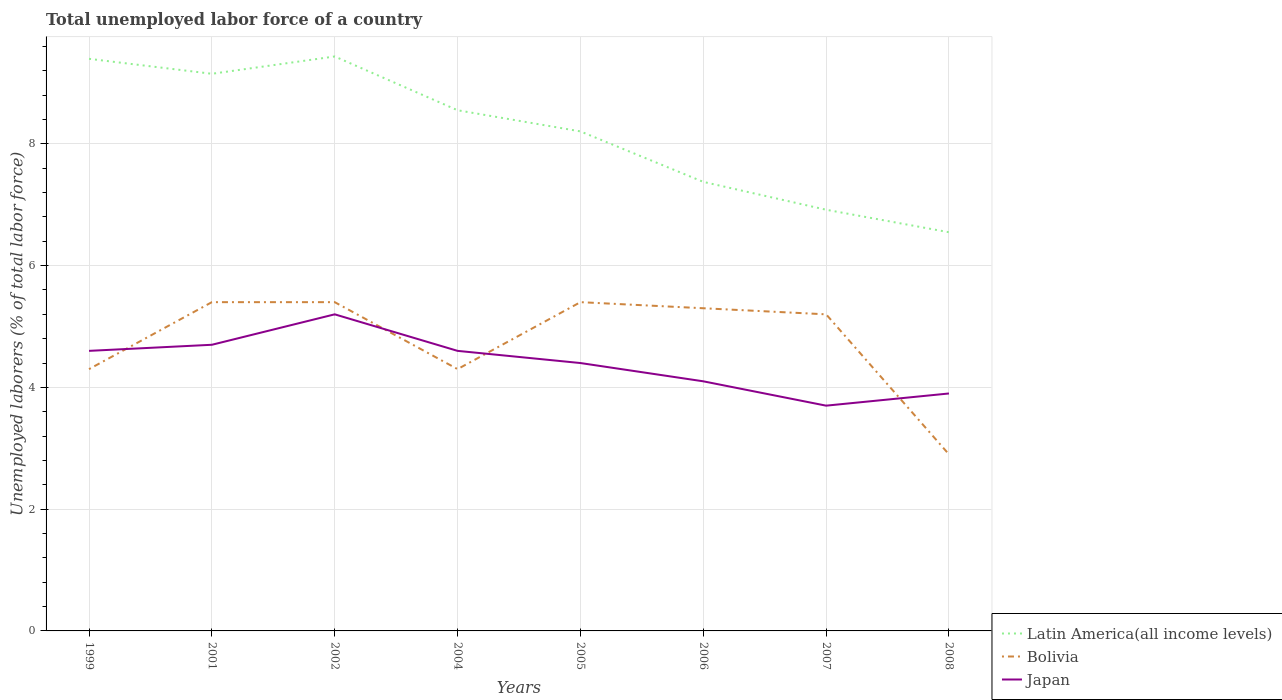Does the line corresponding to Bolivia intersect with the line corresponding to Latin America(all income levels)?
Offer a terse response. No. Is the number of lines equal to the number of legend labels?
Give a very brief answer. Yes. Across all years, what is the maximum total unemployed labor force in Latin America(all income levels)?
Your response must be concise. 6.55. In which year was the total unemployed labor force in Japan maximum?
Your response must be concise. 2007. What is the total total unemployed labor force in Japan in the graph?
Your answer should be compact. 0.9. What is the difference between the highest and the second highest total unemployed labor force in Bolivia?
Offer a terse response. 2.5. Is the total unemployed labor force in Bolivia strictly greater than the total unemployed labor force in Japan over the years?
Keep it short and to the point. No. How many years are there in the graph?
Give a very brief answer. 8. What is the difference between two consecutive major ticks on the Y-axis?
Your answer should be compact. 2. Are the values on the major ticks of Y-axis written in scientific E-notation?
Your answer should be compact. No. Does the graph contain grids?
Provide a succinct answer. Yes. How are the legend labels stacked?
Make the answer very short. Vertical. What is the title of the graph?
Your answer should be compact. Total unemployed labor force of a country. Does "Azerbaijan" appear as one of the legend labels in the graph?
Ensure brevity in your answer.  No. What is the label or title of the X-axis?
Offer a terse response. Years. What is the label or title of the Y-axis?
Your response must be concise. Unemployed laborers (% of total labor force). What is the Unemployed laborers (% of total labor force) of Latin America(all income levels) in 1999?
Your answer should be compact. 9.4. What is the Unemployed laborers (% of total labor force) of Bolivia in 1999?
Provide a short and direct response. 4.3. What is the Unemployed laborers (% of total labor force) of Japan in 1999?
Your answer should be very brief. 4.6. What is the Unemployed laborers (% of total labor force) of Latin America(all income levels) in 2001?
Your answer should be very brief. 9.15. What is the Unemployed laborers (% of total labor force) in Bolivia in 2001?
Your answer should be very brief. 5.4. What is the Unemployed laborers (% of total labor force) of Japan in 2001?
Your answer should be very brief. 4.7. What is the Unemployed laborers (% of total labor force) of Latin America(all income levels) in 2002?
Give a very brief answer. 9.44. What is the Unemployed laborers (% of total labor force) of Bolivia in 2002?
Your answer should be compact. 5.4. What is the Unemployed laborers (% of total labor force) in Japan in 2002?
Ensure brevity in your answer.  5.2. What is the Unemployed laborers (% of total labor force) of Latin America(all income levels) in 2004?
Offer a terse response. 8.55. What is the Unemployed laborers (% of total labor force) of Bolivia in 2004?
Provide a short and direct response. 4.3. What is the Unemployed laborers (% of total labor force) in Japan in 2004?
Offer a very short reply. 4.6. What is the Unemployed laborers (% of total labor force) in Latin America(all income levels) in 2005?
Give a very brief answer. 8.2. What is the Unemployed laborers (% of total labor force) of Bolivia in 2005?
Your answer should be compact. 5.4. What is the Unemployed laborers (% of total labor force) in Japan in 2005?
Offer a very short reply. 4.4. What is the Unemployed laborers (% of total labor force) of Latin America(all income levels) in 2006?
Your answer should be compact. 7.38. What is the Unemployed laborers (% of total labor force) of Bolivia in 2006?
Offer a very short reply. 5.3. What is the Unemployed laborers (% of total labor force) of Japan in 2006?
Make the answer very short. 4.1. What is the Unemployed laborers (% of total labor force) in Latin America(all income levels) in 2007?
Offer a terse response. 6.92. What is the Unemployed laborers (% of total labor force) in Bolivia in 2007?
Your answer should be very brief. 5.2. What is the Unemployed laborers (% of total labor force) of Japan in 2007?
Provide a short and direct response. 3.7. What is the Unemployed laborers (% of total labor force) in Latin America(all income levels) in 2008?
Give a very brief answer. 6.55. What is the Unemployed laborers (% of total labor force) of Bolivia in 2008?
Provide a succinct answer. 2.9. What is the Unemployed laborers (% of total labor force) of Japan in 2008?
Give a very brief answer. 3.9. Across all years, what is the maximum Unemployed laborers (% of total labor force) of Latin America(all income levels)?
Offer a very short reply. 9.44. Across all years, what is the maximum Unemployed laborers (% of total labor force) of Bolivia?
Ensure brevity in your answer.  5.4. Across all years, what is the maximum Unemployed laborers (% of total labor force) of Japan?
Provide a succinct answer. 5.2. Across all years, what is the minimum Unemployed laborers (% of total labor force) in Latin America(all income levels)?
Your response must be concise. 6.55. Across all years, what is the minimum Unemployed laborers (% of total labor force) in Bolivia?
Your answer should be very brief. 2.9. Across all years, what is the minimum Unemployed laborers (% of total labor force) of Japan?
Ensure brevity in your answer.  3.7. What is the total Unemployed laborers (% of total labor force) in Latin America(all income levels) in the graph?
Your answer should be very brief. 65.58. What is the total Unemployed laborers (% of total labor force) in Bolivia in the graph?
Give a very brief answer. 38.2. What is the total Unemployed laborers (% of total labor force) of Japan in the graph?
Make the answer very short. 35.2. What is the difference between the Unemployed laborers (% of total labor force) in Latin America(all income levels) in 1999 and that in 2001?
Provide a succinct answer. 0.25. What is the difference between the Unemployed laborers (% of total labor force) in Latin America(all income levels) in 1999 and that in 2002?
Offer a terse response. -0.04. What is the difference between the Unemployed laborers (% of total labor force) of Japan in 1999 and that in 2002?
Make the answer very short. -0.6. What is the difference between the Unemployed laborers (% of total labor force) in Latin America(all income levels) in 1999 and that in 2004?
Offer a very short reply. 0.84. What is the difference between the Unemployed laborers (% of total labor force) of Bolivia in 1999 and that in 2004?
Your response must be concise. 0. What is the difference between the Unemployed laborers (% of total labor force) of Japan in 1999 and that in 2004?
Offer a very short reply. 0. What is the difference between the Unemployed laborers (% of total labor force) of Latin America(all income levels) in 1999 and that in 2005?
Provide a succinct answer. 1.19. What is the difference between the Unemployed laborers (% of total labor force) of Latin America(all income levels) in 1999 and that in 2006?
Provide a succinct answer. 2.02. What is the difference between the Unemployed laborers (% of total labor force) of Bolivia in 1999 and that in 2006?
Keep it short and to the point. -1. What is the difference between the Unemployed laborers (% of total labor force) of Japan in 1999 and that in 2006?
Make the answer very short. 0.5. What is the difference between the Unemployed laborers (% of total labor force) of Latin America(all income levels) in 1999 and that in 2007?
Offer a terse response. 2.48. What is the difference between the Unemployed laborers (% of total labor force) of Bolivia in 1999 and that in 2007?
Provide a succinct answer. -0.9. What is the difference between the Unemployed laborers (% of total labor force) in Latin America(all income levels) in 1999 and that in 2008?
Your answer should be compact. 2.85. What is the difference between the Unemployed laborers (% of total labor force) of Latin America(all income levels) in 2001 and that in 2002?
Your answer should be compact. -0.28. What is the difference between the Unemployed laborers (% of total labor force) in Japan in 2001 and that in 2002?
Make the answer very short. -0.5. What is the difference between the Unemployed laborers (% of total labor force) of Latin America(all income levels) in 2001 and that in 2004?
Your answer should be compact. 0.6. What is the difference between the Unemployed laborers (% of total labor force) in Latin America(all income levels) in 2001 and that in 2005?
Give a very brief answer. 0.95. What is the difference between the Unemployed laborers (% of total labor force) in Bolivia in 2001 and that in 2005?
Ensure brevity in your answer.  0. What is the difference between the Unemployed laborers (% of total labor force) in Japan in 2001 and that in 2005?
Give a very brief answer. 0.3. What is the difference between the Unemployed laborers (% of total labor force) of Latin America(all income levels) in 2001 and that in 2006?
Provide a short and direct response. 1.78. What is the difference between the Unemployed laborers (% of total labor force) in Japan in 2001 and that in 2006?
Make the answer very short. 0.6. What is the difference between the Unemployed laborers (% of total labor force) of Latin America(all income levels) in 2001 and that in 2007?
Your answer should be compact. 2.23. What is the difference between the Unemployed laborers (% of total labor force) in Latin America(all income levels) in 2001 and that in 2008?
Give a very brief answer. 2.6. What is the difference between the Unemployed laborers (% of total labor force) in Bolivia in 2001 and that in 2008?
Make the answer very short. 2.5. What is the difference between the Unemployed laborers (% of total labor force) of Latin America(all income levels) in 2002 and that in 2004?
Your answer should be very brief. 0.88. What is the difference between the Unemployed laborers (% of total labor force) of Japan in 2002 and that in 2004?
Offer a terse response. 0.6. What is the difference between the Unemployed laborers (% of total labor force) of Latin America(all income levels) in 2002 and that in 2005?
Provide a succinct answer. 1.23. What is the difference between the Unemployed laborers (% of total labor force) in Bolivia in 2002 and that in 2005?
Provide a short and direct response. 0. What is the difference between the Unemployed laborers (% of total labor force) in Latin America(all income levels) in 2002 and that in 2006?
Your answer should be very brief. 2.06. What is the difference between the Unemployed laborers (% of total labor force) in Latin America(all income levels) in 2002 and that in 2007?
Offer a terse response. 2.52. What is the difference between the Unemployed laborers (% of total labor force) in Latin America(all income levels) in 2002 and that in 2008?
Your response must be concise. 2.89. What is the difference between the Unemployed laborers (% of total labor force) in Japan in 2002 and that in 2008?
Give a very brief answer. 1.3. What is the difference between the Unemployed laborers (% of total labor force) of Latin America(all income levels) in 2004 and that in 2005?
Make the answer very short. 0.35. What is the difference between the Unemployed laborers (% of total labor force) in Bolivia in 2004 and that in 2005?
Make the answer very short. -1.1. What is the difference between the Unemployed laborers (% of total labor force) of Latin America(all income levels) in 2004 and that in 2006?
Your answer should be compact. 1.18. What is the difference between the Unemployed laborers (% of total labor force) in Japan in 2004 and that in 2006?
Make the answer very short. 0.5. What is the difference between the Unemployed laborers (% of total labor force) in Latin America(all income levels) in 2004 and that in 2007?
Your response must be concise. 1.63. What is the difference between the Unemployed laborers (% of total labor force) of Japan in 2004 and that in 2007?
Keep it short and to the point. 0.9. What is the difference between the Unemployed laborers (% of total labor force) in Latin America(all income levels) in 2004 and that in 2008?
Your answer should be compact. 2. What is the difference between the Unemployed laborers (% of total labor force) of Latin America(all income levels) in 2005 and that in 2006?
Your answer should be compact. 0.83. What is the difference between the Unemployed laborers (% of total labor force) of Latin America(all income levels) in 2005 and that in 2007?
Your answer should be very brief. 1.29. What is the difference between the Unemployed laborers (% of total labor force) of Latin America(all income levels) in 2005 and that in 2008?
Offer a terse response. 1.66. What is the difference between the Unemployed laborers (% of total labor force) in Bolivia in 2005 and that in 2008?
Provide a succinct answer. 2.5. What is the difference between the Unemployed laborers (% of total labor force) of Japan in 2005 and that in 2008?
Your answer should be compact. 0.5. What is the difference between the Unemployed laborers (% of total labor force) in Latin America(all income levels) in 2006 and that in 2007?
Your response must be concise. 0.46. What is the difference between the Unemployed laborers (% of total labor force) in Latin America(all income levels) in 2006 and that in 2008?
Provide a succinct answer. 0.83. What is the difference between the Unemployed laborers (% of total labor force) of Japan in 2006 and that in 2008?
Keep it short and to the point. 0.2. What is the difference between the Unemployed laborers (% of total labor force) in Latin America(all income levels) in 2007 and that in 2008?
Offer a terse response. 0.37. What is the difference between the Unemployed laborers (% of total labor force) in Bolivia in 2007 and that in 2008?
Provide a succinct answer. 2.3. What is the difference between the Unemployed laborers (% of total labor force) of Japan in 2007 and that in 2008?
Give a very brief answer. -0.2. What is the difference between the Unemployed laborers (% of total labor force) in Latin America(all income levels) in 1999 and the Unemployed laborers (% of total labor force) in Bolivia in 2001?
Keep it short and to the point. 4. What is the difference between the Unemployed laborers (% of total labor force) of Latin America(all income levels) in 1999 and the Unemployed laborers (% of total labor force) of Japan in 2001?
Your response must be concise. 4.7. What is the difference between the Unemployed laborers (% of total labor force) in Bolivia in 1999 and the Unemployed laborers (% of total labor force) in Japan in 2001?
Give a very brief answer. -0.4. What is the difference between the Unemployed laborers (% of total labor force) of Latin America(all income levels) in 1999 and the Unemployed laborers (% of total labor force) of Bolivia in 2002?
Provide a short and direct response. 4. What is the difference between the Unemployed laborers (% of total labor force) in Latin America(all income levels) in 1999 and the Unemployed laborers (% of total labor force) in Japan in 2002?
Offer a very short reply. 4.2. What is the difference between the Unemployed laborers (% of total labor force) in Latin America(all income levels) in 1999 and the Unemployed laborers (% of total labor force) in Bolivia in 2004?
Your answer should be very brief. 5.1. What is the difference between the Unemployed laborers (% of total labor force) of Latin America(all income levels) in 1999 and the Unemployed laborers (% of total labor force) of Japan in 2004?
Provide a succinct answer. 4.8. What is the difference between the Unemployed laborers (% of total labor force) of Bolivia in 1999 and the Unemployed laborers (% of total labor force) of Japan in 2004?
Keep it short and to the point. -0.3. What is the difference between the Unemployed laborers (% of total labor force) in Latin America(all income levels) in 1999 and the Unemployed laborers (% of total labor force) in Bolivia in 2005?
Offer a terse response. 4. What is the difference between the Unemployed laborers (% of total labor force) of Latin America(all income levels) in 1999 and the Unemployed laborers (% of total labor force) of Japan in 2005?
Ensure brevity in your answer.  5. What is the difference between the Unemployed laborers (% of total labor force) in Latin America(all income levels) in 1999 and the Unemployed laborers (% of total labor force) in Bolivia in 2006?
Give a very brief answer. 4.1. What is the difference between the Unemployed laborers (% of total labor force) of Latin America(all income levels) in 1999 and the Unemployed laborers (% of total labor force) of Japan in 2006?
Provide a short and direct response. 5.3. What is the difference between the Unemployed laborers (% of total labor force) in Latin America(all income levels) in 1999 and the Unemployed laborers (% of total labor force) in Bolivia in 2007?
Your response must be concise. 4.2. What is the difference between the Unemployed laborers (% of total labor force) in Latin America(all income levels) in 1999 and the Unemployed laborers (% of total labor force) in Japan in 2007?
Provide a short and direct response. 5.7. What is the difference between the Unemployed laborers (% of total labor force) in Bolivia in 1999 and the Unemployed laborers (% of total labor force) in Japan in 2007?
Offer a very short reply. 0.6. What is the difference between the Unemployed laborers (% of total labor force) of Latin America(all income levels) in 1999 and the Unemployed laborers (% of total labor force) of Bolivia in 2008?
Your answer should be very brief. 6.5. What is the difference between the Unemployed laborers (% of total labor force) of Latin America(all income levels) in 1999 and the Unemployed laborers (% of total labor force) of Japan in 2008?
Your answer should be very brief. 5.5. What is the difference between the Unemployed laborers (% of total labor force) of Bolivia in 1999 and the Unemployed laborers (% of total labor force) of Japan in 2008?
Offer a terse response. 0.4. What is the difference between the Unemployed laborers (% of total labor force) of Latin America(all income levels) in 2001 and the Unemployed laborers (% of total labor force) of Bolivia in 2002?
Your answer should be compact. 3.75. What is the difference between the Unemployed laborers (% of total labor force) of Latin America(all income levels) in 2001 and the Unemployed laborers (% of total labor force) of Japan in 2002?
Your response must be concise. 3.95. What is the difference between the Unemployed laborers (% of total labor force) in Latin America(all income levels) in 2001 and the Unemployed laborers (% of total labor force) in Bolivia in 2004?
Keep it short and to the point. 4.85. What is the difference between the Unemployed laborers (% of total labor force) in Latin America(all income levels) in 2001 and the Unemployed laborers (% of total labor force) in Japan in 2004?
Ensure brevity in your answer.  4.55. What is the difference between the Unemployed laborers (% of total labor force) in Latin America(all income levels) in 2001 and the Unemployed laborers (% of total labor force) in Bolivia in 2005?
Ensure brevity in your answer.  3.75. What is the difference between the Unemployed laborers (% of total labor force) in Latin America(all income levels) in 2001 and the Unemployed laborers (% of total labor force) in Japan in 2005?
Provide a succinct answer. 4.75. What is the difference between the Unemployed laborers (% of total labor force) in Bolivia in 2001 and the Unemployed laborers (% of total labor force) in Japan in 2005?
Make the answer very short. 1. What is the difference between the Unemployed laborers (% of total labor force) in Latin America(all income levels) in 2001 and the Unemployed laborers (% of total labor force) in Bolivia in 2006?
Your answer should be very brief. 3.85. What is the difference between the Unemployed laborers (% of total labor force) of Latin America(all income levels) in 2001 and the Unemployed laborers (% of total labor force) of Japan in 2006?
Provide a short and direct response. 5.05. What is the difference between the Unemployed laborers (% of total labor force) of Bolivia in 2001 and the Unemployed laborers (% of total labor force) of Japan in 2006?
Your response must be concise. 1.3. What is the difference between the Unemployed laborers (% of total labor force) in Latin America(all income levels) in 2001 and the Unemployed laborers (% of total labor force) in Bolivia in 2007?
Offer a terse response. 3.95. What is the difference between the Unemployed laborers (% of total labor force) of Latin America(all income levels) in 2001 and the Unemployed laborers (% of total labor force) of Japan in 2007?
Your answer should be compact. 5.45. What is the difference between the Unemployed laborers (% of total labor force) in Bolivia in 2001 and the Unemployed laborers (% of total labor force) in Japan in 2007?
Make the answer very short. 1.7. What is the difference between the Unemployed laborers (% of total labor force) in Latin America(all income levels) in 2001 and the Unemployed laborers (% of total labor force) in Bolivia in 2008?
Offer a terse response. 6.25. What is the difference between the Unemployed laborers (% of total labor force) in Latin America(all income levels) in 2001 and the Unemployed laborers (% of total labor force) in Japan in 2008?
Give a very brief answer. 5.25. What is the difference between the Unemployed laborers (% of total labor force) in Latin America(all income levels) in 2002 and the Unemployed laborers (% of total labor force) in Bolivia in 2004?
Provide a succinct answer. 5.14. What is the difference between the Unemployed laborers (% of total labor force) of Latin America(all income levels) in 2002 and the Unemployed laborers (% of total labor force) of Japan in 2004?
Your response must be concise. 4.84. What is the difference between the Unemployed laborers (% of total labor force) of Bolivia in 2002 and the Unemployed laborers (% of total labor force) of Japan in 2004?
Ensure brevity in your answer.  0.8. What is the difference between the Unemployed laborers (% of total labor force) in Latin America(all income levels) in 2002 and the Unemployed laborers (% of total labor force) in Bolivia in 2005?
Provide a short and direct response. 4.04. What is the difference between the Unemployed laborers (% of total labor force) of Latin America(all income levels) in 2002 and the Unemployed laborers (% of total labor force) of Japan in 2005?
Your response must be concise. 5.04. What is the difference between the Unemployed laborers (% of total labor force) in Bolivia in 2002 and the Unemployed laborers (% of total labor force) in Japan in 2005?
Make the answer very short. 1. What is the difference between the Unemployed laborers (% of total labor force) of Latin America(all income levels) in 2002 and the Unemployed laborers (% of total labor force) of Bolivia in 2006?
Offer a very short reply. 4.14. What is the difference between the Unemployed laborers (% of total labor force) in Latin America(all income levels) in 2002 and the Unemployed laborers (% of total labor force) in Japan in 2006?
Ensure brevity in your answer.  5.34. What is the difference between the Unemployed laborers (% of total labor force) of Bolivia in 2002 and the Unemployed laborers (% of total labor force) of Japan in 2006?
Provide a succinct answer. 1.3. What is the difference between the Unemployed laborers (% of total labor force) in Latin America(all income levels) in 2002 and the Unemployed laborers (% of total labor force) in Bolivia in 2007?
Provide a short and direct response. 4.24. What is the difference between the Unemployed laborers (% of total labor force) of Latin America(all income levels) in 2002 and the Unemployed laborers (% of total labor force) of Japan in 2007?
Make the answer very short. 5.74. What is the difference between the Unemployed laborers (% of total labor force) in Bolivia in 2002 and the Unemployed laborers (% of total labor force) in Japan in 2007?
Your response must be concise. 1.7. What is the difference between the Unemployed laborers (% of total labor force) in Latin America(all income levels) in 2002 and the Unemployed laborers (% of total labor force) in Bolivia in 2008?
Offer a very short reply. 6.54. What is the difference between the Unemployed laborers (% of total labor force) in Latin America(all income levels) in 2002 and the Unemployed laborers (% of total labor force) in Japan in 2008?
Provide a succinct answer. 5.54. What is the difference between the Unemployed laborers (% of total labor force) of Bolivia in 2002 and the Unemployed laborers (% of total labor force) of Japan in 2008?
Provide a short and direct response. 1.5. What is the difference between the Unemployed laborers (% of total labor force) in Latin America(all income levels) in 2004 and the Unemployed laborers (% of total labor force) in Bolivia in 2005?
Your answer should be compact. 3.15. What is the difference between the Unemployed laborers (% of total labor force) in Latin America(all income levels) in 2004 and the Unemployed laborers (% of total labor force) in Japan in 2005?
Offer a terse response. 4.15. What is the difference between the Unemployed laborers (% of total labor force) of Latin America(all income levels) in 2004 and the Unemployed laborers (% of total labor force) of Bolivia in 2006?
Give a very brief answer. 3.25. What is the difference between the Unemployed laborers (% of total labor force) in Latin America(all income levels) in 2004 and the Unemployed laborers (% of total labor force) in Japan in 2006?
Offer a very short reply. 4.45. What is the difference between the Unemployed laborers (% of total labor force) of Latin America(all income levels) in 2004 and the Unemployed laborers (% of total labor force) of Bolivia in 2007?
Offer a very short reply. 3.35. What is the difference between the Unemployed laborers (% of total labor force) in Latin America(all income levels) in 2004 and the Unemployed laborers (% of total labor force) in Japan in 2007?
Your answer should be very brief. 4.85. What is the difference between the Unemployed laborers (% of total labor force) of Latin America(all income levels) in 2004 and the Unemployed laborers (% of total labor force) of Bolivia in 2008?
Provide a short and direct response. 5.65. What is the difference between the Unemployed laborers (% of total labor force) of Latin America(all income levels) in 2004 and the Unemployed laborers (% of total labor force) of Japan in 2008?
Your response must be concise. 4.65. What is the difference between the Unemployed laborers (% of total labor force) in Bolivia in 2004 and the Unemployed laborers (% of total labor force) in Japan in 2008?
Provide a succinct answer. 0.4. What is the difference between the Unemployed laborers (% of total labor force) of Latin America(all income levels) in 2005 and the Unemployed laborers (% of total labor force) of Bolivia in 2006?
Offer a very short reply. 2.9. What is the difference between the Unemployed laborers (% of total labor force) of Latin America(all income levels) in 2005 and the Unemployed laborers (% of total labor force) of Japan in 2006?
Make the answer very short. 4.1. What is the difference between the Unemployed laborers (% of total labor force) in Latin America(all income levels) in 2005 and the Unemployed laborers (% of total labor force) in Bolivia in 2007?
Your response must be concise. 3. What is the difference between the Unemployed laborers (% of total labor force) in Latin America(all income levels) in 2005 and the Unemployed laborers (% of total labor force) in Japan in 2007?
Provide a succinct answer. 4.5. What is the difference between the Unemployed laborers (% of total labor force) in Bolivia in 2005 and the Unemployed laborers (% of total labor force) in Japan in 2007?
Ensure brevity in your answer.  1.7. What is the difference between the Unemployed laborers (% of total labor force) in Latin America(all income levels) in 2005 and the Unemployed laborers (% of total labor force) in Bolivia in 2008?
Your answer should be very brief. 5.3. What is the difference between the Unemployed laborers (% of total labor force) in Latin America(all income levels) in 2005 and the Unemployed laborers (% of total labor force) in Japan in 2008?
Make the answer very short. 4.3. What is the difference between the Unemployed laborers (% of total labor force) in Latin America(all income levels) in 2006 and the Unemployed laborers (% of total labor force) in Bolivia in 2007?
Make the answer very short. 2.18. What is the difference between the Unemployed laborers (% of total labor force) of Latin America(all income levels) in 2006 and the Unemployed laborers (% of total labor force) of Japan in 2007?
Your answer should be very brief. 3.68. What is the difference between the Unemployed laborers (% of total labor force) of Bolivia in 2006 and the Unemployed laborers (% of total labor force) of Japan in 2007?
Your response must be concise. 1.6. What is the difference between the Unemployed laborers (% of total labor force) in Latin America(all income levels) in 2006 and the Unemployed laborers (% of total labor force) in Bolivia in 2008?
Offer a terse response. 4.48. What is the difference between the Unemployed laborers (% of total labor force) of Latin America(all income levels) in 2006 and the Unemployed laborers (% of total labor force) of Japan in 2008?
Provide a succinct answer. 3.48. What is the difference between the Unemployed laborers (% of total labor force) of Bolivia in 2006 and the Unemployed laborers (% of total labor force) of Japan in 2008?
Offer a very short reply. 1.4. What is the difference between the Unemployed laborers (% of total labor force) of Latin America(all income levels) in 2007 and the Unemployed laborers (% of total labor force) of Bolivia in 2008?
Keep it short and to the point. 4.02. What is the difference between the Unemployed laborers (% of total labor force) in Latin America(all income levels) in 2007 and the Unemployed laborers (% of total labor force) in Japan in 2008?
Make the answer very short. 3.02. What is the difference between the Unemployed laborers (% of total labor force) of Bolivia in 2007 and the Unemployed laborers (% of total labor force) of Japan in 2008?
Provide a succinct answer. 1.3. What is the average Unemployed laborers (% of total labor force) in Latin America(all income levels) per year?
Offer a very short reply. 8.2. What is the average Unemployed laborers (% of total labor force) in Bolivia per year?
Make the answer very short. 4.78. In the year 1999, what is the difference between the Unemployed laborers (% of total labor force) in Latin America(all income levels) and Unemployed laborers (% of total labor force) in Bolivia?
Your response must be concise. 5.1. In the year 1999, what is the difference between the Unemployed laborers (% of total labor force) of Latin America(all income levels) and Unemployed laborers (% of total labor force) of Japan?
Give a very brief answer. 4.8. In the year 2001, what is the difference between the Unemployed laborers (% of total labor force) in Latin America(all income levels) and Unemployed laborers (% of total labor force) in Bolivia?
Offer a terse response. 3.75. In the year 2001, what is the difference between the Unemployed laborers (% of total labor force) of Latin America(all income levels) and Unemployed laborers (% of total labor force) of Japan?
Provide a succinct answer. 4.45. In the year 2002, what is the difference between the Unemployed laborers (% of total labor force) of Latin America(all income levels) and Unemployed laborers (% of total labor force) of Bolivia?
Offer a terse response. 4.04. In the year 2002, what is the difference between the Unemployed laborers (% of total labor force) in Latin America(all income levels) and Unemployed laborers (% of total labor force) in Japan?
Ensure brevity in your answer.  4.24. In the year 2004, what is the difference between the Unemployed laborers (% of total labor force) of Latin America(all income levels) and Unemployed laborers (% of total labor force) of Bolivia?
Provide a succinct answer. 4.25. In the year 2004, what is the difference between the Unemployed laborers (% of total labor force) in Latin America(all income levels) and Unemployed laborers (% of total labor force) in Japan?
Offer a very short reply. 3.95. In the year 2004, what is the difference between the Unemployed laborers (% of total labor force) in Bolivia and Unemployed laborers (% of total labor force) in Japan?
Offer a terse response. -0.3. In the year 2005, what is the difference between the Unemployed laborers (% of total labor force) in Latin America(all income levels) and Unemployed laborers (% of total labor force) in Bolivia?
Your answer should be very brief. 2.8. In the year 2005, what is the difference between the Unemployed laborers (% of total labor force) in Latin America(all income levels) and Unemployed laborers (% of total labor force) in Japan?
Ensure brevity in your answer.  3.8. In the year 2005, what is the difference between the Unemployed laborers (% of total labor force) in Bolivia and Unemployed laborers (% of total labor force) in Japan?
Your answer should be compact. 1. In the year 2006, what is the difference between the Unemployed laborers (% of total labor force) of Latin America(all income levels) and Unemployed laborers (% of total labor force) of Bolivia?
Provide a short and direct response. 2.08. In the year 2006, what is the difference between the Unemployed laborers (% of total labor force) of Latin America(all income levels) and Unemployed laborers (% of total labor force) of Japan?
Give a very brief answer. 3.28. In the year 2007, what is the difference between the Unemployed laborers (% of total labor force) of Latin America(all income levels) and Unemployed laborers (% of total labor force) of Bolivia?
Your response must be concise. 1.72. In the year 2007, what is the difference between the Unemployed laborers (% of total labor force) of Latin America(all income levels) and Unemployed laborers (% of total labor force) of Japan?
Make the answer very short. 3.22. In the year 2008, what is the difference between the Unemployed laborers (% of total labor force) of Latin America(all income levels) and Unemployed laborers (% of total labor force) of Bolivia?
Make the answer very short. 3.65. In the year 2008, what is the difference between the Unemployed laborers (% of total labor force) in Latin America(all income levels) and Unemployed laborers (% of total labor force) in Japan?
Give a very brief answer. 2.65. In the year 2008, what is the difference between the Unemployed laborers (% of total labor force) of Bolivia and Unemployed laborers (% of total labor force) of Japan?
Your response must be concise. -1. What is the ratio of the Unemployed laborers (% of total labor force) in Latin America(all income levels) in 1999 to that in 2001?
Ensure brevity in your answer.  1.03. What is the ratio of the Unemployed laborers (% of total labor force) in Bolivia in 1999 to that in 2001?
Keep it short and to the point. 0.8. What is the ratio of the Unemployed laborers (% of total labor force) in Japan in 1999 to that in 2001?
Provide a short and direct response. 0.98. What is the ratio of the Unemployed laborers (% of total labor force) of Bolivia in 1999 to that in 2002?
Ensure brevity in your answer.  0.8. What is the ratio of the Unemployed laborers (% of total labor force) in Japan in 1999 to that in 2002?
Provide a short and direct response. 0.88. What is the ratio of the Unemployed laborers (% of total labor force) of Latin America(all income levels) in 1999 to that in 2004?
Your answer should be compact. 1.1. What is the ratio of the Unemployed laborers (% of total labor force) in Bolivia in 1999 to that in 2004?
Ensure brevity in your answer.  1. What is the ratio of the Unemployed laborers (% of total labor force) in Japan in 1999 to that in 2004?
Your answer should be very brief. 1. What is the ratio of the Unemployed laborers (% of total labor force) of Latin America(all income levels) in 1999 to that in 2005?
Give a very brief answer. 1.15. What is the ratio of the Unemployed laborers (% of total labor force) of Bolivia in 1999 to that in 2005?
Your response must be concise. 0.8. What is the ratio of the Unemployed laborers (% of total labor force) in Japan in 1999 to that in 2005?
Provide a short and direct response. 1.05. What is the ratio of the Unemployed laborers (% of total labor force) of Latin America(all income levels) in 1999 to that in 2006?
Make the answer very short. 1.27. What is the ratio of the Unemployed laborers (% of total labor force) in Bolivia in 1999 to that in 2006?
Your response must be concise. 0.81. What is the ratio of the Unemployed laborers (% of total labor force) in Japan in 1999 to that in 2006?
Your answer should be compact. 1.12. What is the ratio of the Unemployed laborers (% of total labor force) in Latin America(all income levels) in 1999 to that in 2007?
Give a very brief answer. 1.36. What is the ratio of the Unemployed laborers (% of total labor force) of Bolivia in 1999 to that in 2007?
Your answer should be very brief. 0.83. What is the ratio of the Unemployed laborers (% of total labor force) of Japan in 1999 to that in 2007?
Your answer should be very brief. 1.24. What is the ratio of the Unemployed laborers (% of total labor force) in Latin America(all income levels) in 1999 to that in 2008?
Offer a terse response. 1.44. What is the ratio of the Unemployed laborers (% of total labor force) of Bolivia in 1999 to that in 2008?
Your answer should be compact. 1.48. What is the ratio of the Unemployed laborers (% of total labor force) in Japan in 1999 to that in 2008?
Give a very brief answer. 1.18. What is the ratio of the Unemployed laborers (% of total labor force) in Latin America(all income levels) in 2001 to that in 2002?
Offer a very short reply. 0.97. What is the ratio of the Unemployed laborers (% of total labor force) of Japan in 2001 to that in 2002?
Provide a short and direct response. 0.9. What is the ratio of the Unemployed laborers (% of total labor force) in Latin America(all income levels) in 2001 to that in 2004?
Keep it short and to the point. 1.07. What is the ratio of the Unemployed laborers (% of total labor force) in Bolivia in 2001 to that in 2004?
Your answer should be compact. 1.26. What is the ratio of the Unemployed laborers (% of total labor force) of Japan in 2001 to that in 2004?
Ensure brevity in your answer.  1.02. What is the ratio of the Unemployed laborers (% of total labor force) of Latin America(all income levels) in 2001 to that in 2005?
Offer a terse response. 1.12. What is the ratio of the Unemployed laborers (% of total labor force) in Japan in 2001 to that in 2005?
Provide a short and direct response. 1.07. What is the ratio of the Unemployed laborers (% of total labor force) of Latin America(all income levels) in 2001 to that in 2006?
Your answer should be compact. 1.24. What is the ratio of the Unemployed laborers (% of total labor force) of Bolivia in 2001 to that in 2006?
Provide a succinct answer. 1.02. What is the ratio of the Unemployed laborers (% of total labor force) of Japan in 2001 to that in 2006?
Your answer should be very brief. 1.15. What is the ratio of the Unemployed laborers (% of total labor force) in Latin America(all income levels) in 2001 to that in 2007?
Give a very brief answer. 1.32. What is the ratio of the Unemployed laborers (% of total labor force) in Japan in 2001 to that in 2007?
Provide a short and direct response. 1.27. What is the ratio of the Unemployed laborers (% of total labor force) of Latin America(all income levels) in 2001 to that in 2008?
Ensure brevity in your answer.  1.4. What is the ratio of the Unemployed laborers (% of total labor force) of Bolivia in 2001 to that in 2008?
Ensure brevity in your answer.  1.86. What is the ratio of the Unemployed laborers (% of total labor force) of Japan in 2001 to that in 2008?
Your answer should be very brief. 1.21. What is the ratio of the Unemployed laborers (% of total labor force) in Latin America(all income levels) in 2002 to that in 2004?
Offer a very short reply. 1.1. What is the ratio of the Unemployed laborers (% of total labor force) in Bolivia in 2002 to that in 2004?
Make the answer very short. 1.26. What is the ratio of the Unemployed laborers (% of total labor force) in Japan in 2002 to that in 2004?
Your answer should be very brief. 1.13. What is the ratio of the Unemployed laborers (% of total labor force) of Latin America(all income levels) in 2002 to that in 2005?
Provide a succinct answer. 1.15. What is the ratio of the Unemployed laborers (% of total labor force) in Japan in 2002 to that in 2005?
Your answer should be very brief. 1.18. What is the ratio of the Unemployed laborers (% of total labor force) of Latin America(all income levels) in 2002 to that in 2006?
Provide a short and direct response. 1.28. What is the ratio of the Unemployed laborers (% of total labor force) in Bolivia in 2002 to that in 2006?
Provide a short and direct response. 1.02. What is the ratio of the Unemployed laborers (% of total labor force) of Japan in 2002 to that in 2006?
Keep it short and to the point. 1.27. What is the ratio of the Unemployed laborers (% of total labor force) of Latin America(all income levels) in 2002 to that in 2007?
Make the answer very short. 1.36. What is the ratio of the Unemployed laborers (% of total labor force) of Bolivia in 2002 to that in 2007?
Offer a very short reply. 1.04. What is the ratio of the Unemployed laborers (% of total labor force) of Japan in 2002 to that in 2007?
Provide a succinct answer. 1.41. What is the ratio of the Unemployed laborers (% of total labor force) in Latin America(all income levels) in 2002 to that in 2008?
Your answer should be compact. 1.44. What is the ratio of the Unemployed laborers (% of total labor force) in Bolivia in 2002 to that in 2008?
Your answer should be compact. 1.86. What is the ratio of the Unemployed laborers (% of total labor force) in Latin America(all income levels) in 2004 to that in 2005?
Your response must be concise. 1.04. What is the ratio of the Unemployed laborers (% of total labor force) of Bolivia in 2004 to that in 2005?
Make the answer very short. 0.8. What is the ratio of the Unemployed laborers (% of total labor force) in Japan in 2004 to that in 2005?
Ensure brevity in your answer.  1.05. What is the ratio of the Unemployed laborers (% of total labor force) of Latin America(all income levels) in 2004 to that in 2006?
Offer a terse response. 1.16. What is the ratio of the Unemployed laborers (% of total labor force) of Bolivia in 2004 to that in 2006?
Give a very brief answer. 0.81. What is the ratio of the Unemployed laborers (% of total labor force) in Japan in 2004 to that in 2006?
Your answer should be compact. 1.12. What is the ratio of the Unemployed laborers (% of total labor force) of Latin America(all income levels) in 2004 to that in 2007?
Ensure brevity in your answer.  1.24. What is the ratio of the Unemployed laborers (% of total labor force) in Bolivia in 2004 to that in 2007?
Keep it short and to the point. 0.83. What is the ratio of the Unemployed laborers (% of total labor force) of Japan in 2004 to that in 2007?
Make the answer very short. 1.24. What is the ratio of the Unemployed laborers (% of total labor force) in Latin America(all income levels) in 2004 to that in 2008?
Provide a short and direct response. 1.31. What is the ratio of the Unemployed laborers (% of total labor force) of Bolivia in 2004 to that in 2008?
Give a very brief answer. 1.48. What is the ratio of the Unemployed laborers (% of total labor force) of Japan in 2004 to that in 2008?
Give a very brief answer. 1.18. What is the ratio of the Unemployed laborers (% of total labor force) in Latin America(all income levels) in 2005 to that in 2006?
Offer a terse response. 1.11. What is the ratio of the Unemployed laborers (% of total labor force) of Bolivia in 2005 to that in 2006?
Offer a terse response. 1.02. What is the ratio of the Unemployed laborers (% of total labor force) in Japan in 2005 to that in 2006?
Offer a terse response. 1.07. What is the ratio of the Unemployed laborers (% of total labor force) of Latin America(all income levels) in 2005 to that in 2007?
Make the answer very short. 1.19. What is the ratio of the Unemployed laborers (% of total labor force) of Bolivia in 2005 to that in 2007?
Ensure brevity in your answer.  1.04. What is the ratio of the Unemployed laborers (% of total labor force) of Japan in 2005 to that in 2007?
Keep it short and to the point. 1.19. What is the ratio of the Unemployed laborers (% of total labor force) of Latin America(all income levels) in 2005 to that in 2008?
Provide a short and direct response. 1.25. What is the ratio of the Unemployed laborers (% of total labor force) in Bolivia in 2005 to that in 2008?
Offer a very short reply. 1.86. What is the ratio of the Unemployed laborers (% of total labor force) of Japan in 2005 to that in 2008?
Offer a very short reply. 1.13. What is the ratio of the Unemployed laborers (% of total labor force) in Latin America(all income levels) in 2006 to that in 2007?
Provide a short and direct response. 1.07. What is the ratio of the Unemployed laborers (% of total labor force) in Bolivia in 2006 to that in 2007?
Make the answer very short. 1.02. What is the ratio of the Unemployed laborers (% of total labor force) of Japan in 2006 to that in 2007?
Your answer should be compact. 1.11. What is the ratio of the Unemployed laborers (% of total labor force) of Latin America(all income levels) in 2006 to that in 2008?
Give a very brief answer. 1.13. What is the ratio of the Unemployed laborers (% of total labor force) in Bolivia in 2006 to that in 2008?
Your response must be concise. 1.83. What is the ratio of the Unemployed laborers (% of total labor force) of Japan in 2006 to that in 2008?
Your answer should be compact. 1.05. What is the ratio of the Unemployed laborers (% of total labor force) in Latin America(all income levels) in 2007 to that in 2008?
Give a very brief answer. 1.06. What is the ratio of the Unemployed laborers (% of total labor force) in Bolivia in 2007 to that in 2008?
Provide a short and direct response. 1.79. What is the ratio of the Unemployed laborers (% of total labor force) in Japan in 2007 to that in 2008?
Your answer should be very brief. 0.95. What is the difference between the highest and the second highest Unemployed laborers (% of total labor force) in Latin America(all income levels)?
Your answer should be compact. 0.04. What is the difference between the highest and the lowest Unemployed laborers (% of total labor force) of Latin America(all income levels)?
Provide a succinct answer. 2.89. What is the difference between the highest and the lowest Unemployed laborers (% of total labor force) in Bolivia?
Provide a short and direct response. 2.5. 